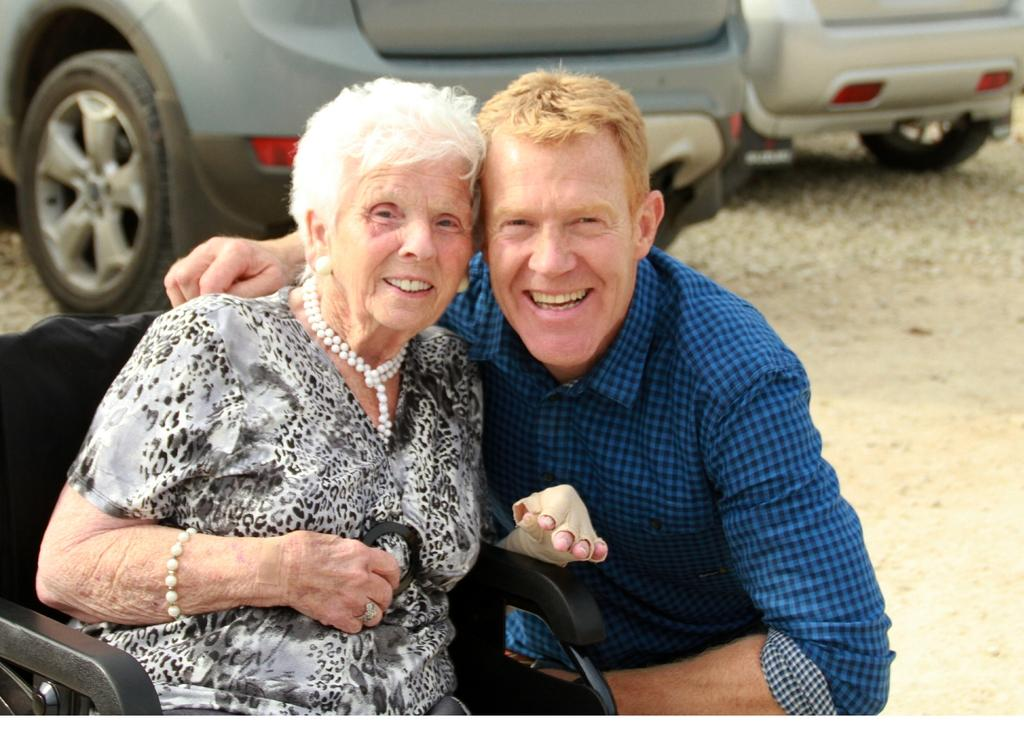How many persons are present in the image? There are persons in the image, but the exact number is not specified. What is the facial expression of the persons in the image? The persons in the image are smiling. What can be seen in the background of the image? There are cars visible in the background of the image. What type of bomb can be seen in the image? There is no bomb present in the image. What type of juice is being consumed by the persons in the image? The image does not show any juice being consumed by the persons. 